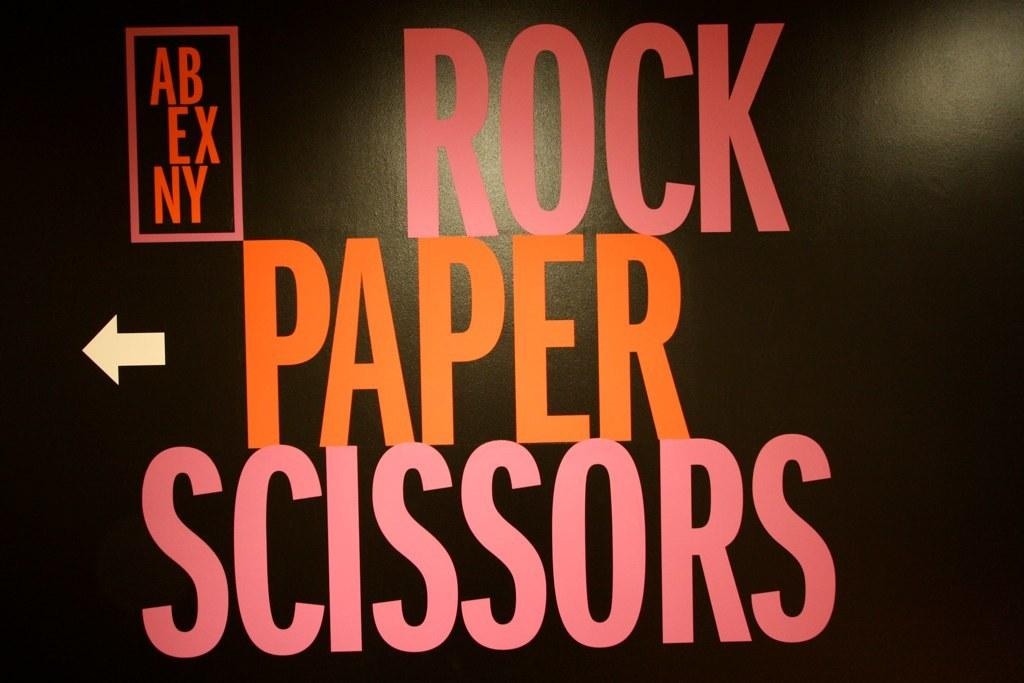What is present on the poster in the image? The content of the poster cannot be determined from the provided facts. What can be seen on the left side of the image? There is an arrow sign on the left side of the image. What color is the background of the image? The background of the image is black. How many ornaments are hanging from the line in the image? There is no line or ornaments present in the image. What type of books can be seen on the bookshelf in the image? There is no bookshelf or books present in the image. 